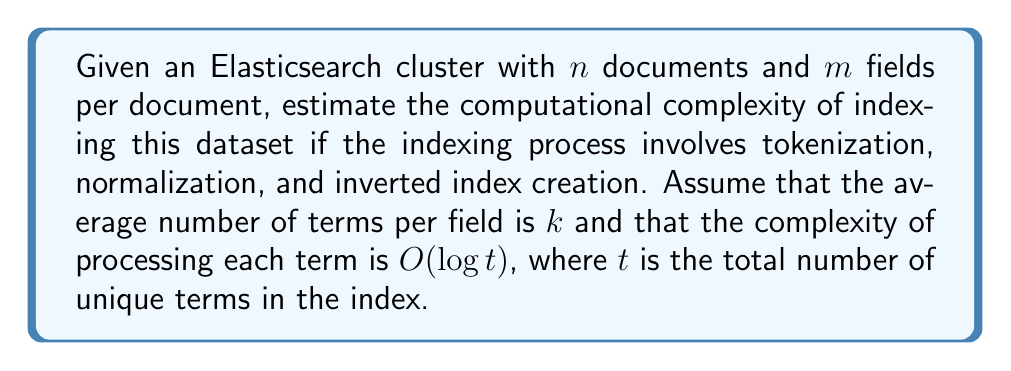What is the answer to this math problem? To estimate the computational complexity, let's break down the indexing process:

1. For each document ($n$ total):
   a. For each field ($m$ per document):
      i. Tokenize and normalize $k$ terms on average
      ii. For each term, update the inverted index: $O(\log t)$

2. The total number of operations can be expressed as:
   $$n \times m \times k \times O(\log t)$$

3. Simplify the expression:
   $$O(nmk \log t)$$

4. In big O notation, we typically express complexity in terms of the input size. Here, the input size is primarily determined by the number of documents $n$, as it's usually the largest variable.

5. The number of fields $m$ is typically constant or grows very slowly compared to $n$, so we can consider it a constant factor.

6. The average number of terms per field $k$ can vary but is often relatively stable across documents, so we can also treat it as a constant factor.

7. The total number of unique terms $t$ grows sublinearly with respect to $n$, often approximated as $O(n^\beta)$ where $0 < \beta < 1$. A common estimate is $\beta \approx 0.5$.

8. Substituting $t$ with $n^{0.5}$:
   $$O(nmk \log (n^{0.5})) = O(nmk \log \sqrt{n}) = O(nmk \cdot \frac{1}{2} \log n) = O(nmk \log n)$$

9. Since $m$ and $k$ are treated as constants, we can simplify to:
   $$O(n \log n)$$

This represents a linearithmic time complexity for indexing large datasets in Elasticsearch.
Answer: $O(n \log n)$ 